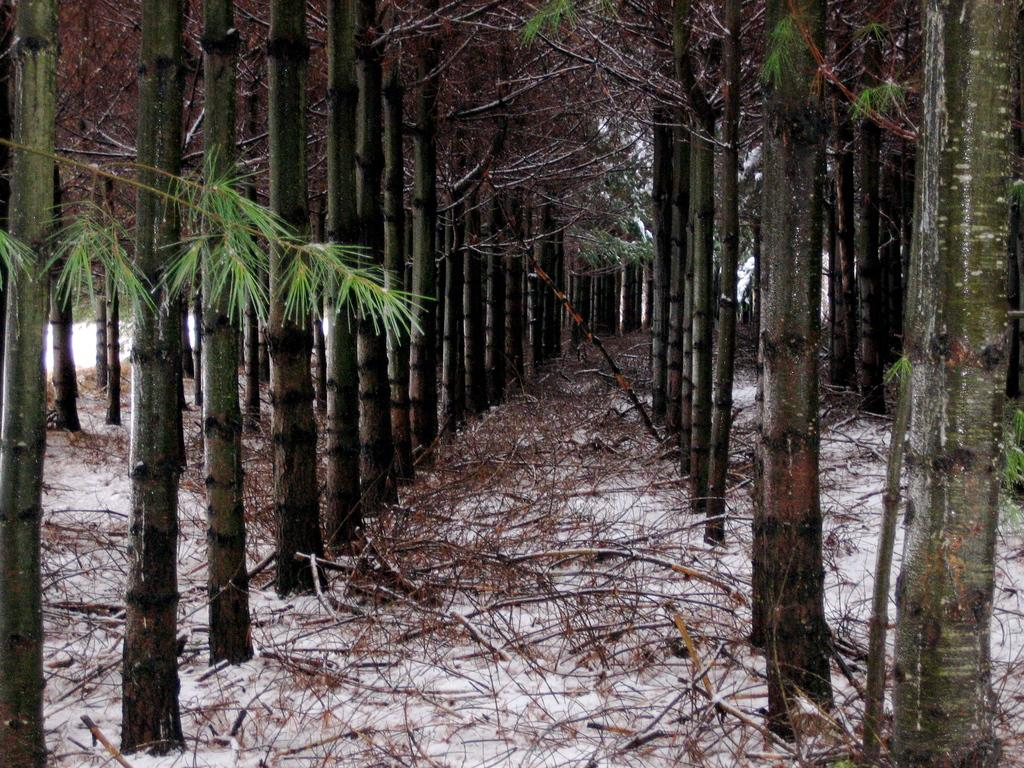What type of vegetation can be seen in the image? There are trees in the image. What is the weather like in the image? There is snow visible in the image, indicating a cold or wintry environment. What objects can be seen in the image besides the trees? There are sticks visible in the image. What type of haircut is popular in the downtown area depicted in the image? There is no downtown area or indication of a haircut in the image; it primarily features trees and snow. 